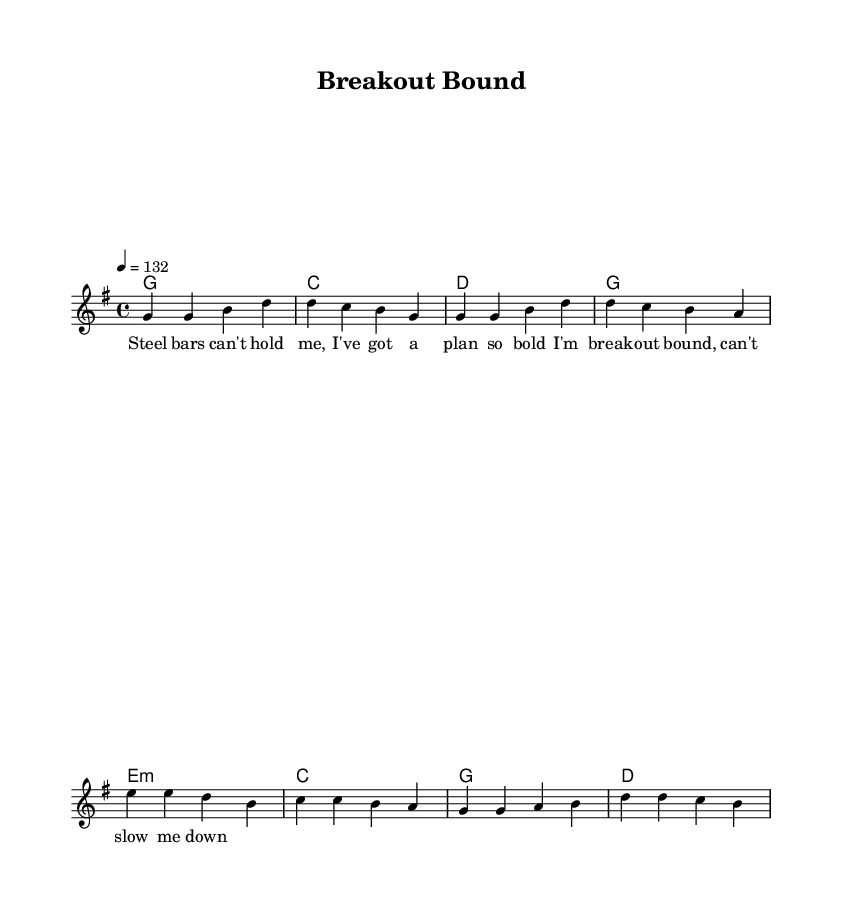What is the key signature of this music? The key signature is G major, which has one sharp (F#). This is indicated at the beginning of the sheet music.
Answer: G major What is the time signature of this music? The time signature is 4/4, which means there are four beats in each measure and the quarter note gets one beat. This is indicated at the beginning of the sheet music.
Answer: 4/4 What is the tempo marking for this piece? The tempo marking is 132 beats per minute, indicated as "4 = 132" at the beginning of the sheet music. This means there are 132 beats in one minute.
Answer: 132 How many measures are in the verse of the song? The verse consists of four measures, which are clearly outlined in the melody section with notes grouped together into measures.
Answer: 4 What are the chord changes in the chorus? The chorus has four chords: E minor, C, G, and D, represented in the chord names section. The progression is based on the structure typically found in Country Rock.
Answer: E minor, C, G, D What lyrical theme is reflected in the verse? The verse reflects a theme of determination and freedom, emphasizing a bold escape plan from confinement. This can be inferred from the lyrics provided.
Answer: Determination What distinguishes this piece as Country Rock? This piece includes themes related to prison escapes and manhunts, which are commonly found in Country Rock music, along with a mix of folk narrative style and strong rhythms.
Answer: Daring themes 